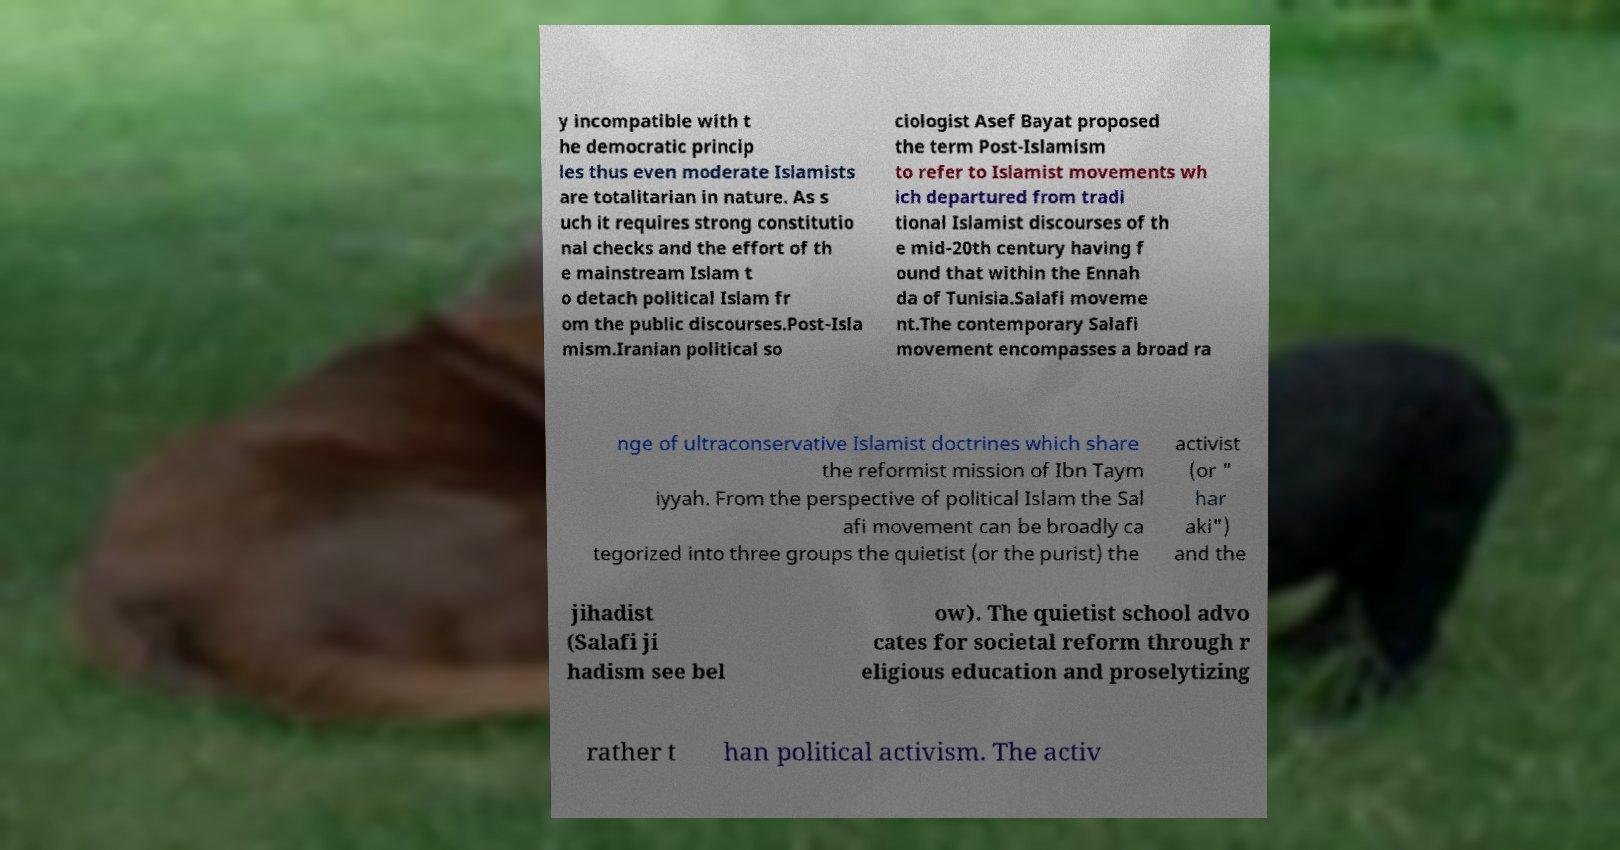For documentation purposes, I need the text within this image transcribed. Could you provide that? y incompatible with t he democratic princip les thus even moderate Islamists are totalitarian in nature. As s uch it requires strong constitutio nal checks and the effort of th e mainstream Islam t o detach political Islam fr om the public discourses.Post-Isla mism.Iranian political so ciologist Asef Bayat proposed the term Post-Islamism to refer to Islamist movements wh ich departured from tradi tional Islamist discourses of th e mid-20th century having f ound that within the Ennah da of Tunisia.Salafi moveme nt.The contemporary Salafi movement encompasses a broad ra nge of ultraconservative Islamist doctrines which share the reformist mission of Ibn Taym iyyah. From the perspective of political Islam the Sal afi movement can be broadly ca tegorized into three groups the quietist (or the purist) the activist (or " har aki") and the jihadist (Salafi ji hadism see bel ow). The quietist school advo cates for societal reform through r eligious education and proselytizing rather t han political activism. The activ 